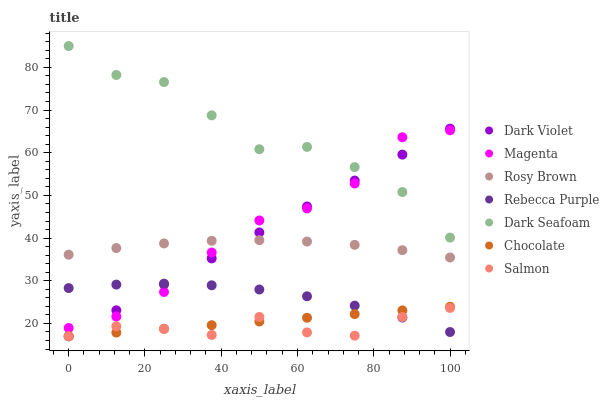Does Salmon have the minimum area under the curve?
Answer yes or no. Yes. Does Dark Seafoam have the maximum area under the curve?
Answer yes or no. Yes. Does Dark Violet have the minimum area under the curve?
Answer yes or no. No. Does Dark Violet have the maximum area under the curve?
Answer yes or no. No. Is Chocolate the smoothest?
Answer yes or no. Yes. Is Dark Seafoam the roughest?
Answer yes or no. Yes. Is Salmon the smoothest?
Answer yes or no. No. Is Salmon the roughest?
Answer yes or no. No. Does Salmon have the lowest value?
Answer yes or no. Yes. Does Dark Seafoam have the lowest value?
Answer yes or no. No. Does Dark Seafoam have the highest value?
Answer yes or no. Yes. Does Dark Violet have the highest value?
Answer yes or no. No. Is Rosy Brown less than Dark Seafoam?
Answer yes or no. Yes. Is Rosy Brown greater than Rebecca Purple?
Answer yes or no. Yes. Does Chocolate intersect Salmon?
Answer yes or no. Yes. Is Chocolate less than Salmon?
Answer yes or no. No. Is Chocolate greater than Salmon?
Answer yes or no. No. Does Rosy Brown intersect Dark Seafoam?
Answer yes or no. No. 